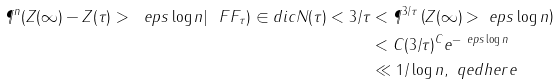<formula> <loc_0><loc_0><loc_500><loc_500>\P ^ { n } ( Z ( \infty ) - Z ( \tau ) > \ e p s \log n | \ F F _ { \tau } ) \in d i c { N ( \tau ) < 3 / \tau } & < \P ^ { 3 / \tau } \left ( Z ( \infty ) > \ e p s \log n \right ) \\ & < C ( 3 / \tau ) ^ { C } e ^ { - \ e p s \log n } \\ & \ll 1 / \log n , \ q e d h e r e</formula> 